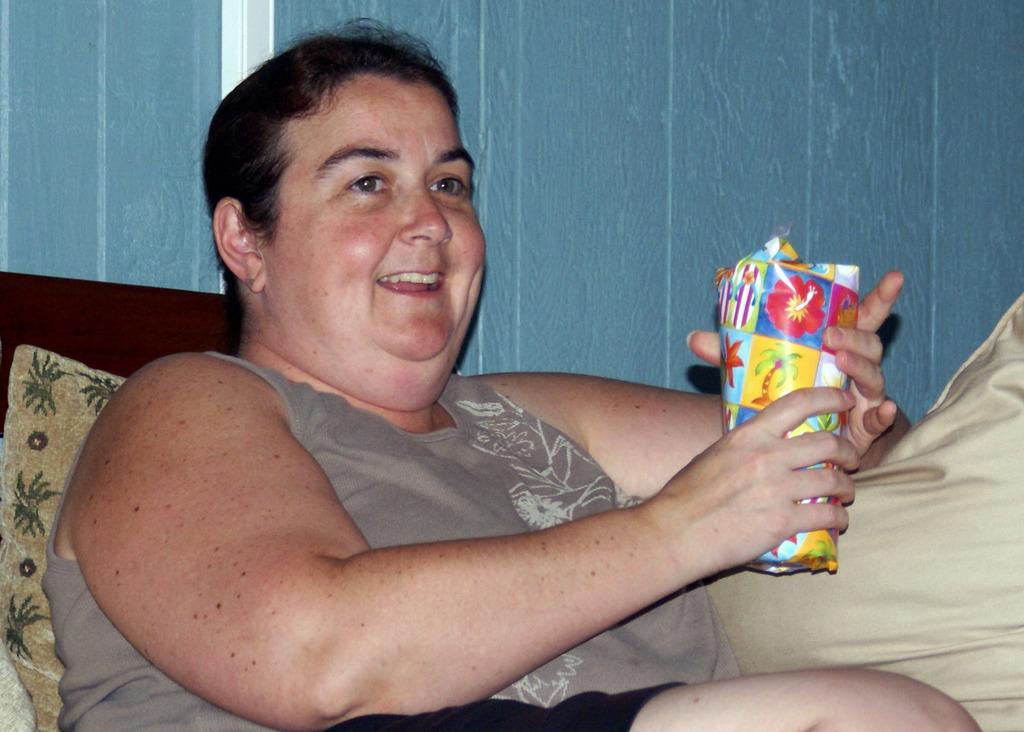Can you describe this image briefly? In this picture we can see a woman holding a object with her hands and smiling and in the background we can see wall. 